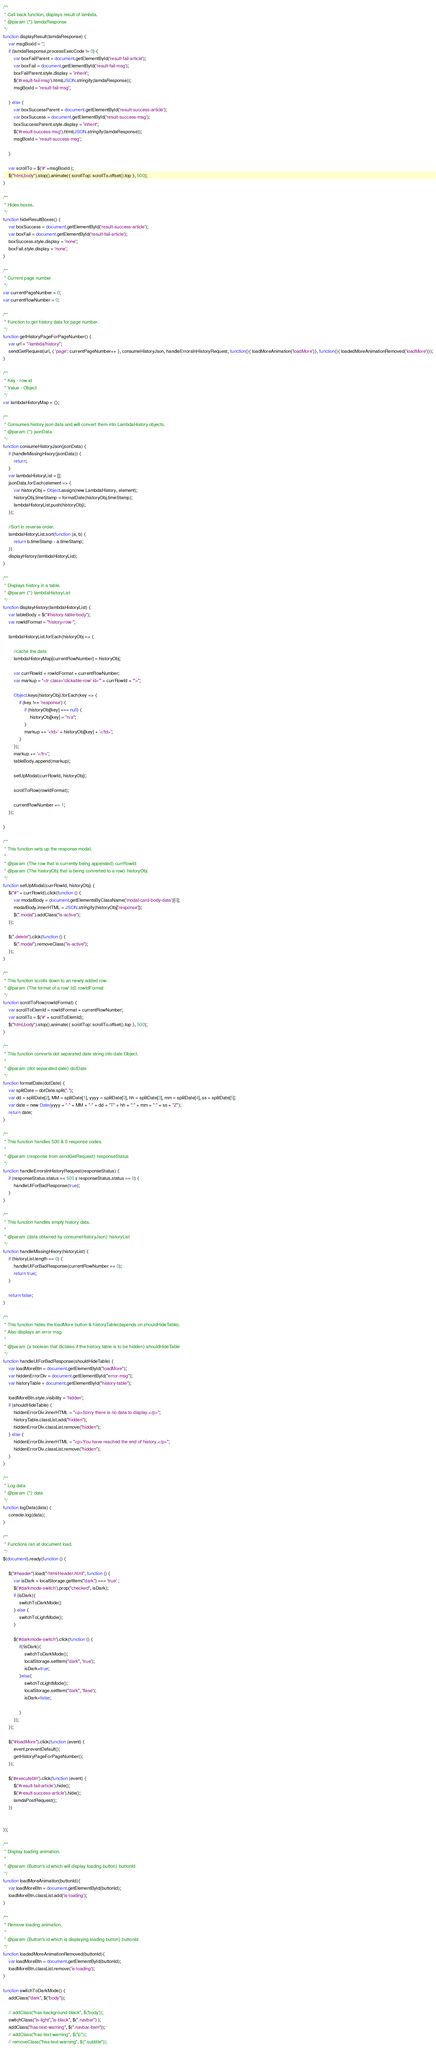Convert code to text. <code><loc_0><loc_0><loc_500><loc_500><_JavaScript_>
/**
 * Call back function, displays result of lambda.
 * @param {*} lamdaResponse
 */
function displayResult(lamdaResponse) {
    var msgBoxId = '';
    if (lamdaResponse.processExecCode != 0) {
        var boxFailParent = document.getElementById('result-fail-article');
        var boxFail = document.getElementById('result-fail-msg');
        boxFailParent.style.display = 'inherit';
        $('#result-fail-msg').html(JSON.stringify(lamdaResponse));
        msgBoxId = 'result-fail-msg';

    } else {
        var boxSuccessParent = document.getElementById('result-success-article');
        var boxSuccess = document.getElementById('result-success-msg');
        boxSuccessParent.style.display = 'inherit';
        $('#result-success-msg').html(JSON.stringify(lamdaResponse));
        msgBoxId = 'result-success-msg';

    }

    var scrollTo = $('#' +msgBoxId );
    $("html,body").stop().animate({ scrollTop: scrollTo.offset().top }, 500);
}

/**
 * Hides boxes.
 */
function hideResultBoxes() {
    var boxSuccess = document.getElementById('result-success-article');
    var boxFail = document.getElementById('result-fail-article');
    boxSuccess.style.display = 'none';
    boxFail.style.display = 'none';
}

/**
 * Current page number
 */
var currentPageNumber = 0;
var currentRowNumber = 0;

/**
 * Function to get history data for page number.
 */
function getHistoryPageForPageNumber() {
    var url = "/lambda/history";
    sendGetRequest(url, { 'page': currentPageNumber++ }, consumeHistoryJson, handleErrorsInHistoryRequest, function(){ loadMoreAnimation('loadMore')}, function(){ loadedMoreAnimationRemoved('loadMore')});
}

/**
 * Key - row id
 * Value - Object
 */
var lambdaHistoryMap = {};

/**
 * Consumes history json data and will convert them into LambdaHistory objects.
 * @param {*} jsonData
 */
function consumeHistoryJson(jsonData) {
    if (handleMissingHisory(jsonData)) {
        return;
    }
    var lambdaHistoryList = [];
    jsonData.forEach(element => {
        var historyObj = Object.assign(new LambdaHistory, element);
        historyObj.timeStamp = formatDate(historyObj.timeStamp);
        lambdaHistoryList.push(historyObj);
    });

    //Sort in reverse order.
    lambdaHistoryList.sort(function (a, b) {
        return b.timeStamp - a.timeStamp;
    })
    displayHistory(lambdaHistoryList);
}

/**
 * Displays history in a table.
 * @param {*} lambdaHistoryList
 */
function displayHistory(lambdaHistoryList) {
    var tableBody = $("#history-table-body");
    var rowIdFormat = "history-row-";

    lambdaHistoryList.forEach(historyObj => {

        //cache the data
        lambdaHistoryMap[currentRowNumber] = historyObj;

        var currRowId = rowIdFormat + currentRowNumber;
        var markup = "<tr class='clickable-row' id='" + currRowId + "'>";

        Object.keys(historyObj).forEach(key => {
            if (key !== 'response') {
                if (historyObj[key] === null) {
                    historyObj[key] = "n/a";
                }
                markup += '<td>' + historyObj[key] + '</td>';
            }
        });
        markup += '</tr>';
        tableBody.append(markup);

        setUpModal(currRowId, historyObj);

        scrollToRow(rowIdFormat);

        currentRowNumber += 1;
    });

}

/**
 * This function sets up the response modal.
 *
 * @param {The row that is currently being appended} currRowId
 * @param {The historyObj that is being converted to a row} historyObj
 */
function setUpModal(currRowId, historyObj) {
    $("#" + currRowId).click(function () {
        var modalBody = document.getElementsByClassName('modal-card-body-data')[0];
        modalBody.innerHTML = JSON.stringify(historyObj['response']);
        $(".modal").addClass("is-active");
    });

    $(".delete").click(function () {
        $(".modal").removeClass("is-active");
    });
}

/**
 * This function scrolls down to an newly added row.
 * @param {The format of a row' Id} rowIdFormat
 */
function scrollToRow(rowIdFormat) {
    var scrollToElemId = rowIdFormat + currentRowNumber;
    var scrollTo = $('#' + scrollToElemId);
    $("html,body").stop().animate({ scrollTop: scrollTo.offset().top }, 500);
}

/**
 * This function converts dot separated date string into date Object.
 *
 * @param {dot separated date} dotDate
 */
function formatDate(dotDate) {
    var splitDate = dotDate.split(".");
    var dd = splitDate[2], MM = splitDate[1], yyyy = splitDate[0], hh = splitDate[3], mm = splitDate[4], ss = splitDate[5];
    var date = new Date(yyyy + "-" + MM + "-" + dd + "T" + hh + ":" + mm + ":" + ss + "Z");
    return date;
}

/**
 * This function handles 500 & 0 response codes.
 *
 * @param {response from sendGetRequest} responseStatus
 */
function handleErrorsInHistoryRequest(responseStatus) {
    if (responseStatus.status == 500 || responseStatus.status == 0) {
        handleUIForBadResponse(true);
    }
}

/**
 * This function handles empty history data.
 *
 * @param {data obtained by consumeHistoryJson} historyList
 */
function handleMissingHisory(historyList) {
    if (historyList.length == 0) {
        handleUIForBadResponse(currentRowNumber == 0);
        return true;
    }

    return false;
}

/**
 * This function hides the loadMore button & historyTable(depends on shouldHideTable).
 * Also displays an error msg.
 *
 * @param {a boolean that dictates if the history table is to be hidden} shouldHideTable
 */
function handleUIForBadResponse(shouldHideTable) {
    var loadMoreBtn = document.getElementById("loadMore");
    var hiddenErrorDiv = document.getElementById("error-msg");
    var historyTable = document.getElementById("history-table");

    loadMoreBtn.style.visibility = 'hidden';
    if (shouldHideTable) {
        hiddenErrorDiv.innerHTML = "<p>Sorry there is no data to display.</p>";
        historyTable.classList.add("hidden");
        hiddenErrorDiv.classList.remove("hidden");
    } else {
        hiddenErrorDiv.innerHTML = "<p>You have reached the end of history.</p>";
        hiddenErrorDiv.classList.remove("hidden");
    }
}

/**
 * Log data
 * @param {*} data
 */
function logData(data) {
    console.log(data);
}

/**
 * Functions ran at document load.
 */
$(document).ready(function () {

    $("#header").load("/html/Header.html", function () {
        var isDark = localStorage.getItem("dark") === 'true' ;
        $('#darkmode-switch').prop("checked", isDark);
        if (isDark){
            switchToDarkMode()
        } else {
            switchToLightMode();
        }

        $('#darkmode-switch').click(function () {
            if(!isDark){
                switchToDarkMode();
                localStorage.setItem("dark", 'true');
                isDark=true;
            }else{
                switchToLightMode();
                localStorage.setItem("dark", 'flase');
                isDark=false;

            }
        });
    });

    $("#loadMore").click(function (event) {
        event.preventDefault();
        getHistoryPageForPageNumber();
    });

    $('#executebtn').click(function (event) {
        $('#result-fail-article').hide();
        $('#result-success-article').hide();
        lamdaPostRequest();
    })


});

/**
 * Display loading animation.
 *
 * @param {Button's id which will display loading button} buttonId
 */
function loadMoreAnimation(buttonId){
    var loadMoreBtn = document.getElementById(buttonId);
    loadMoreBtn.classList.add('is-loading');
}

/**
 * Remove loading animation.
 *
 * @param {Button's id which is displaying loading button} buttonId
 */
function loadedMoreAnimationRemoved(buttonId){
    var loadMoreBtn = document.getElementById(buttonId);
    loadMoreBtn.classList.remove('is-loading');
}

function switchToDarkMode() {
    addClass("dark", $("body"));

    // addClass("has-background-black", $('body'));
    switchClass("is-light","is-black", $(".navbar") );
    addClass("has-text-warning", $(".navbar-item"));
    // addClass("has-text-warning", $("p"));
    // removeClass("has-text-warning", $(".subtitle"));</code> 